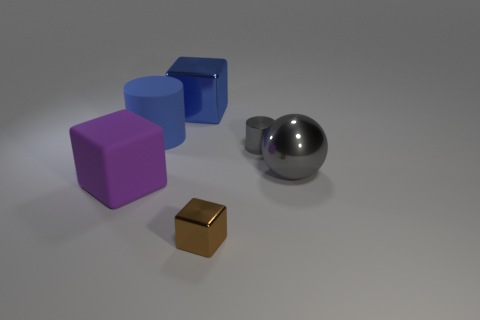Are there fewer purple things behind the purple thing than metallic spheres behind the big blue cylinder?
Provide a short and direct response. No. Is there any other thing that has the same material as the large purple cube?
Make the answer very short. Yes. What is the shape of the large gray thing that is the same material as the brown thing?
Ensure brevity in your answer.  Sphere. Is there anything else that has the same color as the metal cylinder?
Provide a succinct answer. Yes. What is the color of the metallic block that is in front of the tiny metallic thing behind the small brown block?
Provide a short and direct response. Brown. What material is the cylinder on the right side of the metal cube in front of the large cylinder that is behind the big purple object made of?
Your answer should be compact. Metal. How many cylinders are the same size as the blue matte object?
Offer a terse response. 0. What material is the object that is both in front of the tiny gray cylinder and to the right of the tiny metal block?
Your answer should be very brief. Metal. There is a big blue metal thing; how many rubber cylinders are left of it?
Make the answer very short. 1. There is a purple rubber thing; does it have the same shape as the small shiny thing that is to the right of the tiny brown metallic block?
Ensure brevity in your answer.  No. 